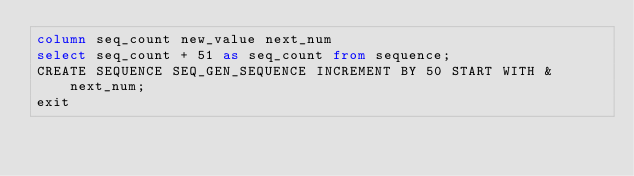Convert code to text. <code><loc_0><loc_0><loc_500><loc_500><_SQL_>column seq_count new_value next_num
select seq_count + 51 as seq_count from sequence;
CREATE SEQUENCE SEQ_GEN_SEQUENCE INCREMENT BY 50 START WITH &next_num;
exit</code> 